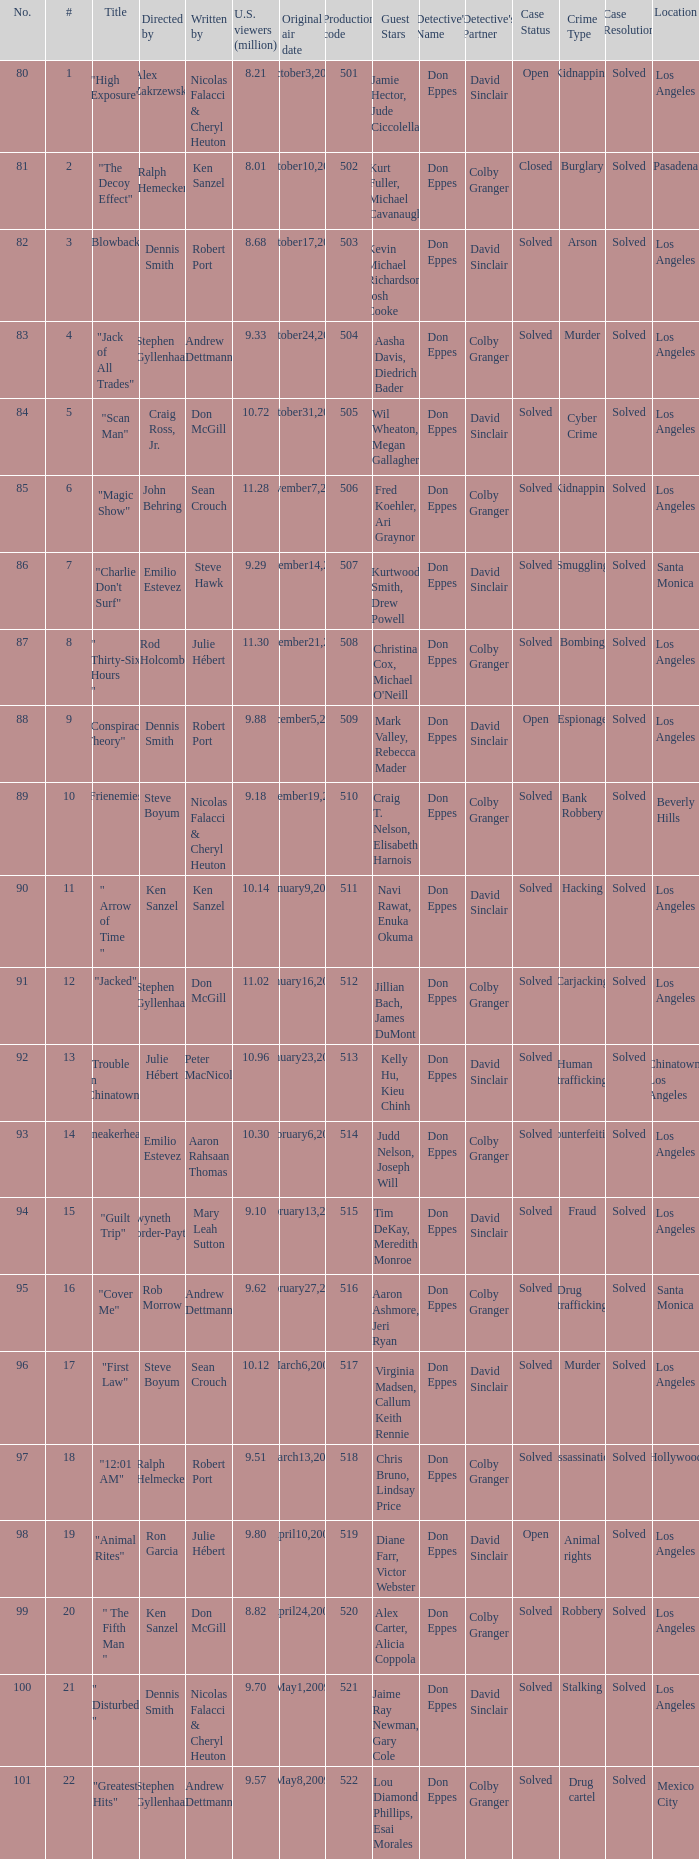How many times did episode 6 originally air? 1.0. 